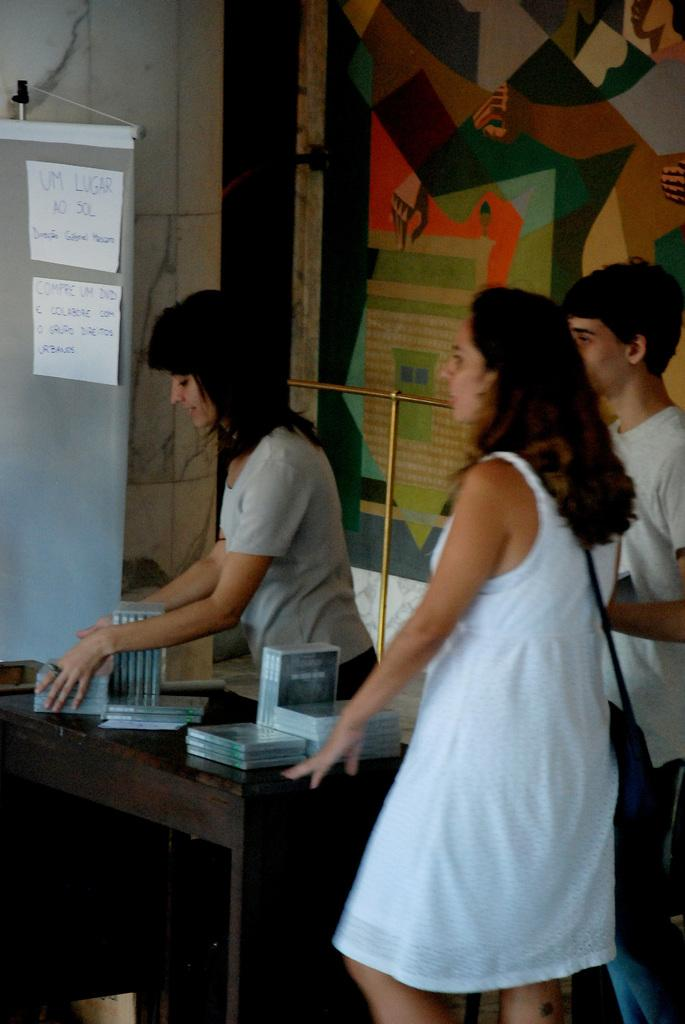How many people are in the image? There are two women and a man in the image. What are the people in the image doing? They are standing at a table. What objects can be seen on the table? There are CDs on the table. What can be seen in the background of the image? There is a wall in the background of the image, with posters on it, and a hoarding. What type of clover is growing on the table in the image? There is no clover present on the table in the image. Is the man in the image holding a ball? There is no ball visible in the image, and the man's hands are not shown. 